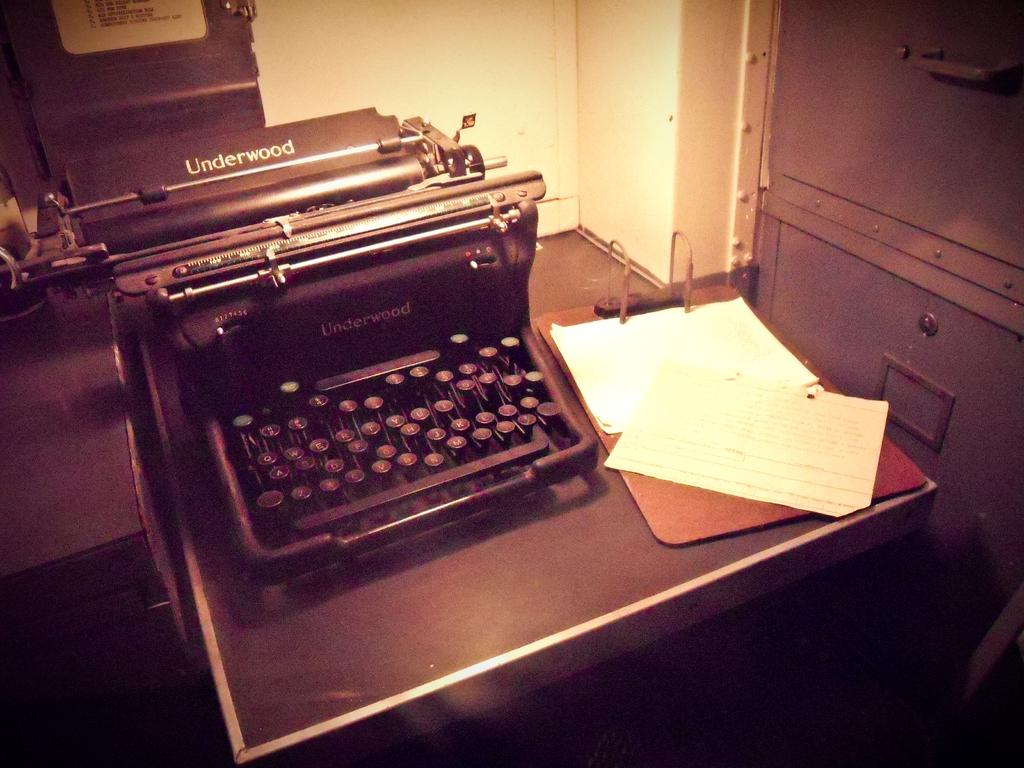<image>
Offer a succinct explanation of the picture presented. An old Underwood manual typewriter on a table next to a clipboard. 